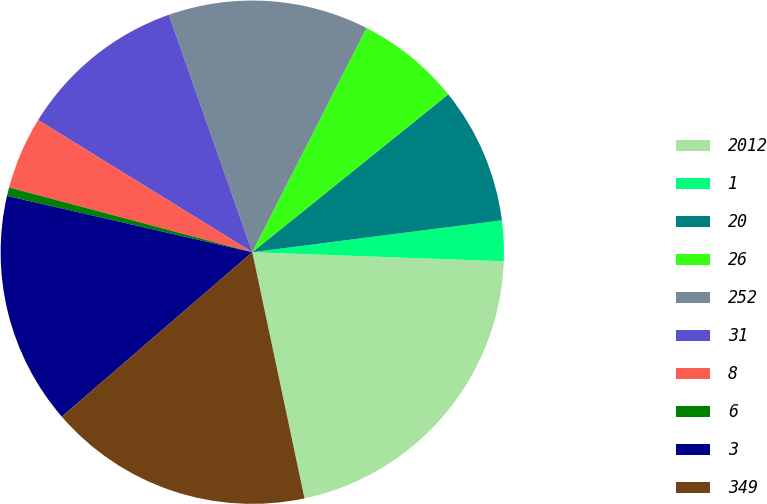Convert chart. <chart><loc_0><loc_0><loc_500><loc_500><pie_chart><fcel>2012<fcel>1<fcel>20<fcel>26<fcel>252<fcel>31<fcel>8<fcel>6<fcel>3<fcel>349<nl><fcel>21.1%<fcel>2.6%<fcel>8.77%<fcel>6.71%<fcel>12.88%<fcel>10.82%<fcel>4.66%<fcel>0.55%<fcel>14.93%<fcel>16.99%<nl></chart> 